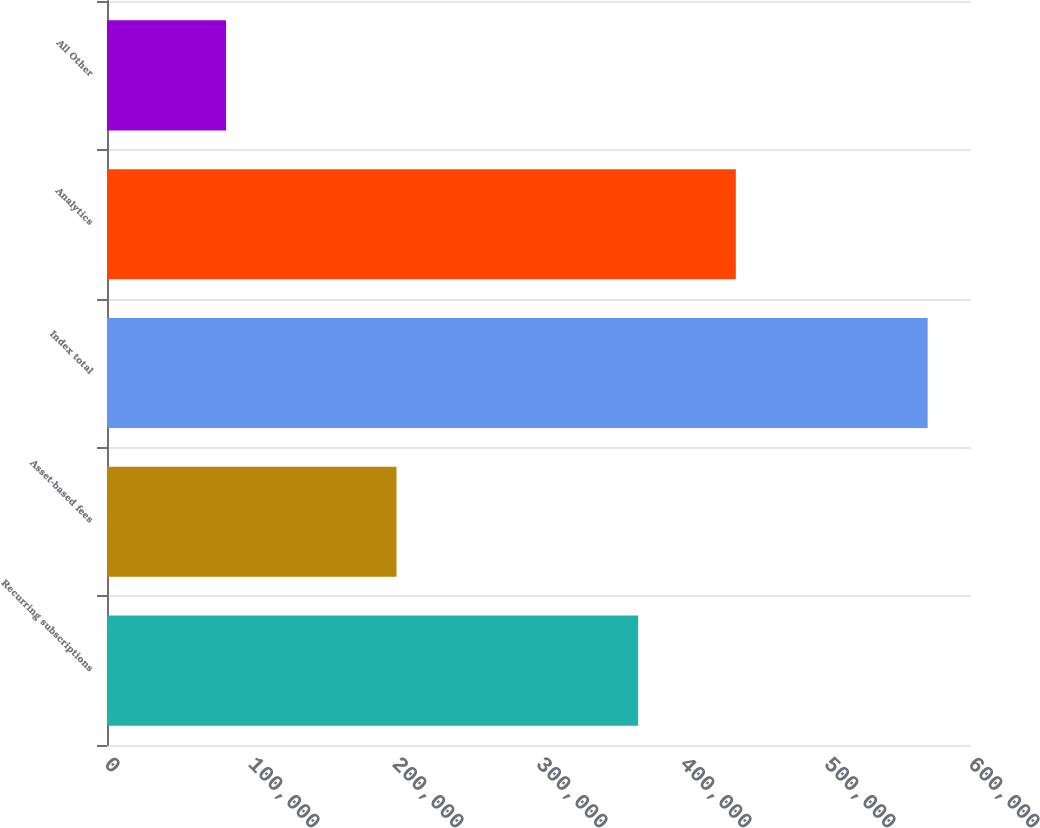Convert chart. <chart><loc_0><loc_0><loc_500><loc_500><bar_chart><fcel>Recurring subscriptions<fcel>Asset-based fees<fcel>Index total<fcel>Analytics<fcel>All Other<nl><fcel>368855<fcel>201047<fcel>569902<fcel>436671<fcel>82677<nl></chart> 